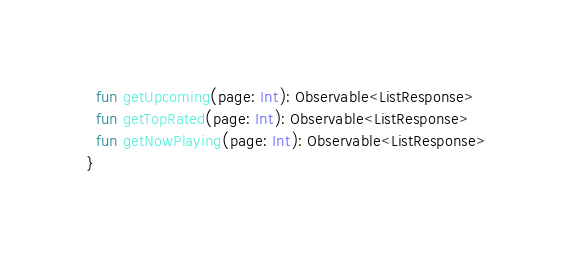Convert code to text. <code><loc_0><loc_0><loc_500><loc_500><_Kotlin_>  fun getUpcoming(page: Int): Observable<ListResponse>
  fun getTopRated(page: Int): Observable<ListResponse>
  fun getNowPlaying(page: Int): Observable<ListResponse>
}</code> 